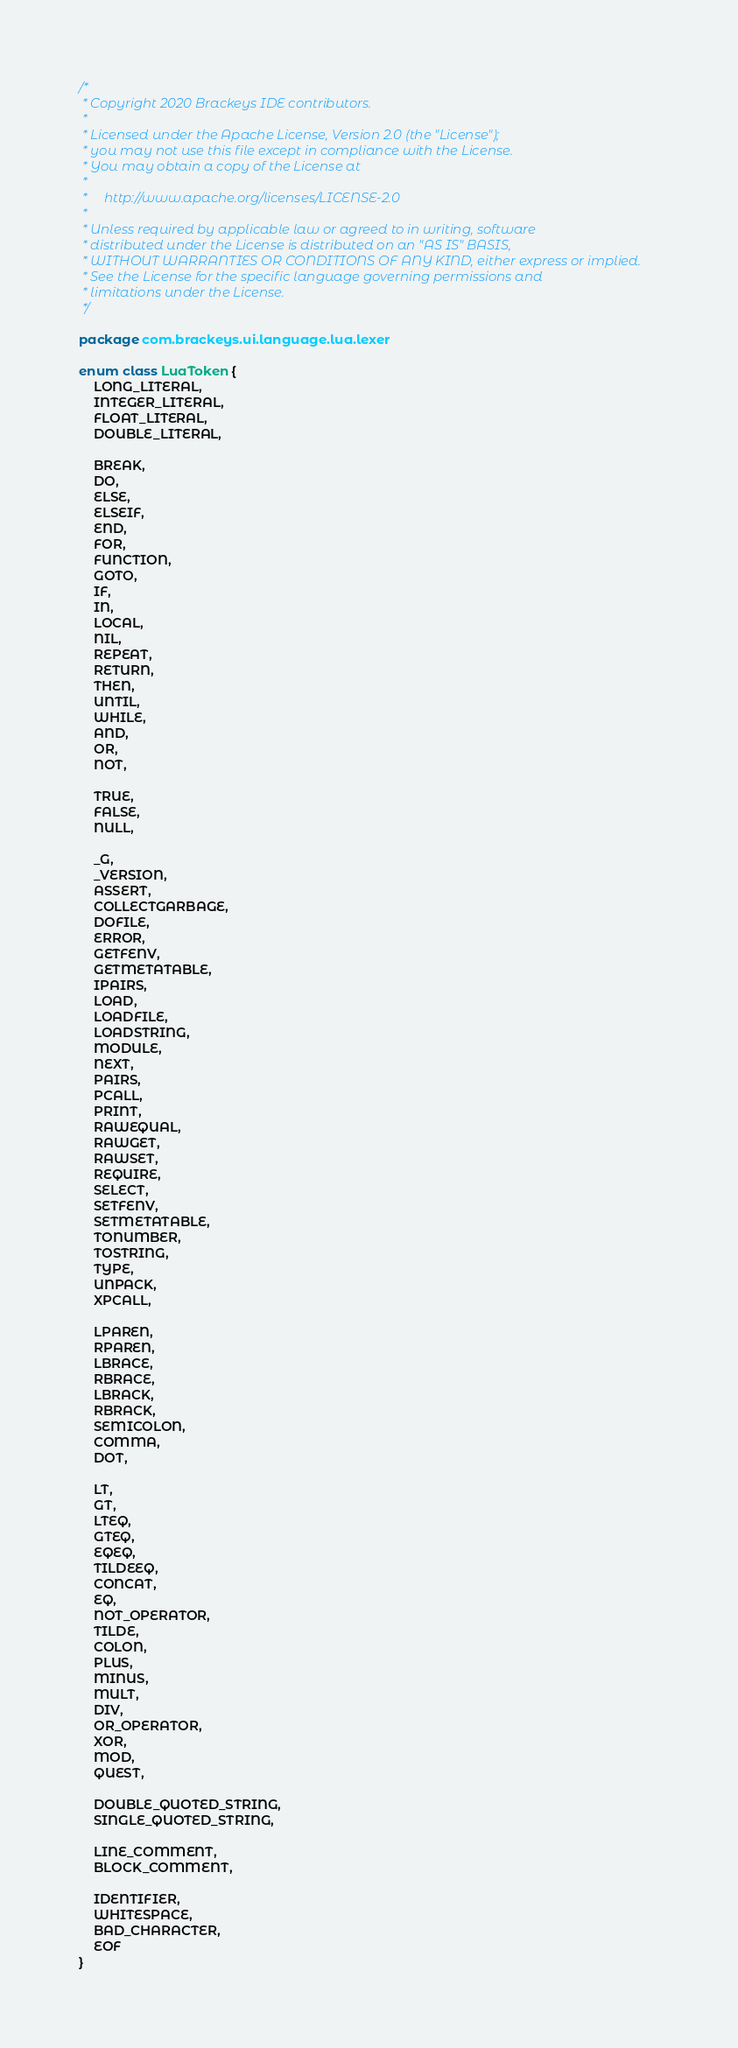<code> <loc_0><loc_0><loc_500><loc_500><_Kotlin_>/*
 * Copyright 2020 Brackeys IDE contributors.
 *
 * Licensed under the Apache License, Version 2.0 (the "License");
 * you may not use this file except in compliance with the License.
 * You may obtain a copy of the License at
 *
 *     http://www.apache.org/licenses/LICENSE-2.0
 *
 * Unless required by applicable law or agreed to in writing, software
 * distributed under the License is distributed on an "AS IS" BASIS,
 * WITHOUT WARRANTIES OR CONDITIONS OF ANY KIND, either express or implied.
 * See the License for the specific language governing permissions and
 * limitations under the License.
 */

package com.brackeys.ui.language.lua.lexer

enum class LuaToken {
    LONG_LITERAL,
    INTEGER_LITERAL,
    FLOAT_LITERAL,
    DOUBLE_LITERAL,

    BREAK,
    DO,
    ELSE,
    ELSEIF,
    END,
    FOR,
    FUNCTION,
    GOTO,
    IF,
    IN,
    LOCAL,
    NIL,
    REPEAT,
    RETURN,
    THEN,
    UNTIL,
    WHILE,
    AND,
    OR,
    NOT,

    TRUE,
    FALSE,
    NULL,

    _G,
    _VERSION,
    ASSERT,
    COLLECTGARBAGE,
    DOFILE,
    ERROR,
    GETFENV,
    GETMETATABLE,
    IPAIRS,
    LOAD,
    LOADFILE,
    LOADSTRING,
    MODULE,
    NEXT,
    PAIRS,
    PCALL,
    PRINT,
    RAWEQUAL,
    RAWGET,
    RAWSET,
    REQUIRE,
    SELECT,
    SETFENV,
    SETMETATABLE,
    TONUMBER,
    TOSTRING,
    TYPE,
    UNPACK,
    XPCALL,

    LPAREN,
    RPAREN,
    LBRACE,
    RBRACE,
    LBRACK,
    RBRACK,
    SEMICOLON,
    COMMA,
    DOT,

    LT,
    GT,
    LTEQ,
    GTEQ,
    EQEQ,
    TILDEEQ,
    CONCAT,
    EQ,
    NOT_OPERATOR,
    TILDE,
    COLON,
    PLUS,
    MINUS,
    MULT,
    DIV,
    OR_OPERATOR,
    XOR,
    MOD,
    QUEST,

    DOUBLE_QUOTED_STRING,
    SINGLE_QUOTED_STRING,

    LINE_COMMENT,
    BLOCK_COMMENT,

    IDENTIFIER,
    WHITESPACE,
    BAD_CHARACTER,
    EOF
}</code> 